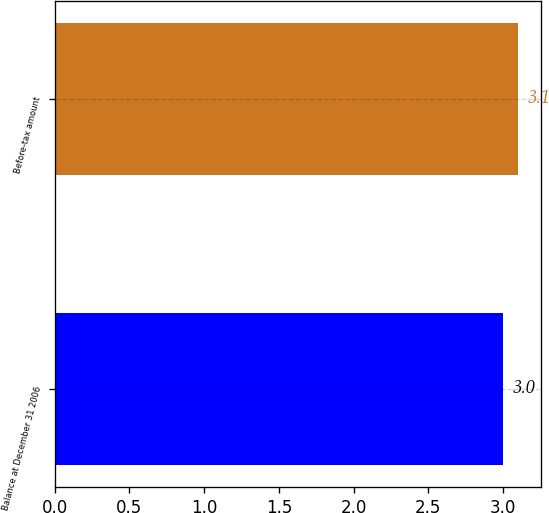<chart> <loc_0><loc_0><loc_500><loc_500><bar_chart><fcel>Balance at December 31 2006<fcel>Before-tax amount<nl><fcel>3<fcel>3.1<nl></chart> 